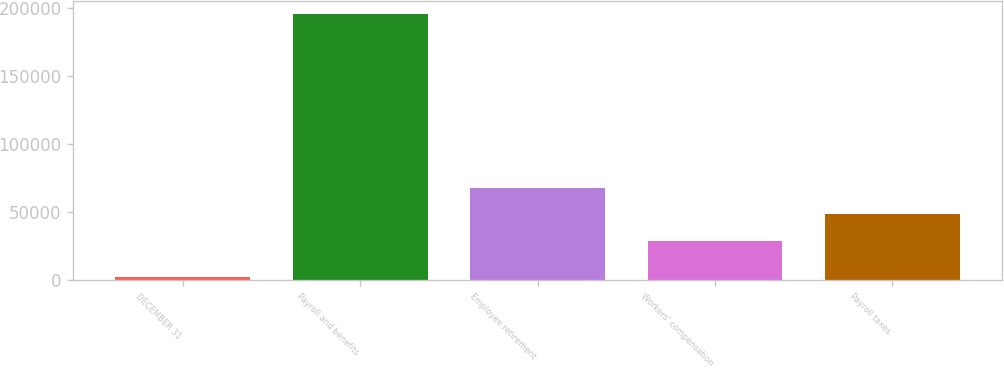Convert chart to OTSL. <chart><loc_0><loc_0><loc_500><loc_500><bar_chart><fcel>DECEMBER 31<fcel>Payroll and benefits<fcel>Employee retirement<fcel>Workers' compensation<fcel>Payroll taxes<nl><fcel>2007<fcel>195383<fcel>67671.2<fcel>28996<fcel>48333.6<nl></chart> 